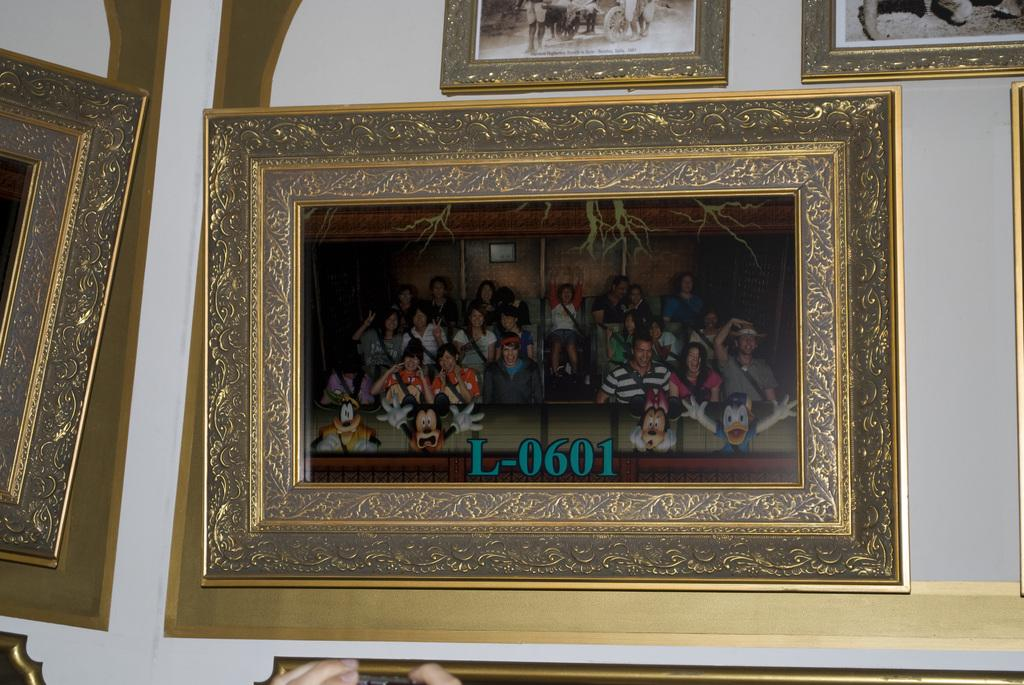<image>
Give a short and clear explanation of the subsequent image. a painting with golden frame on the wall numbered L-0601 